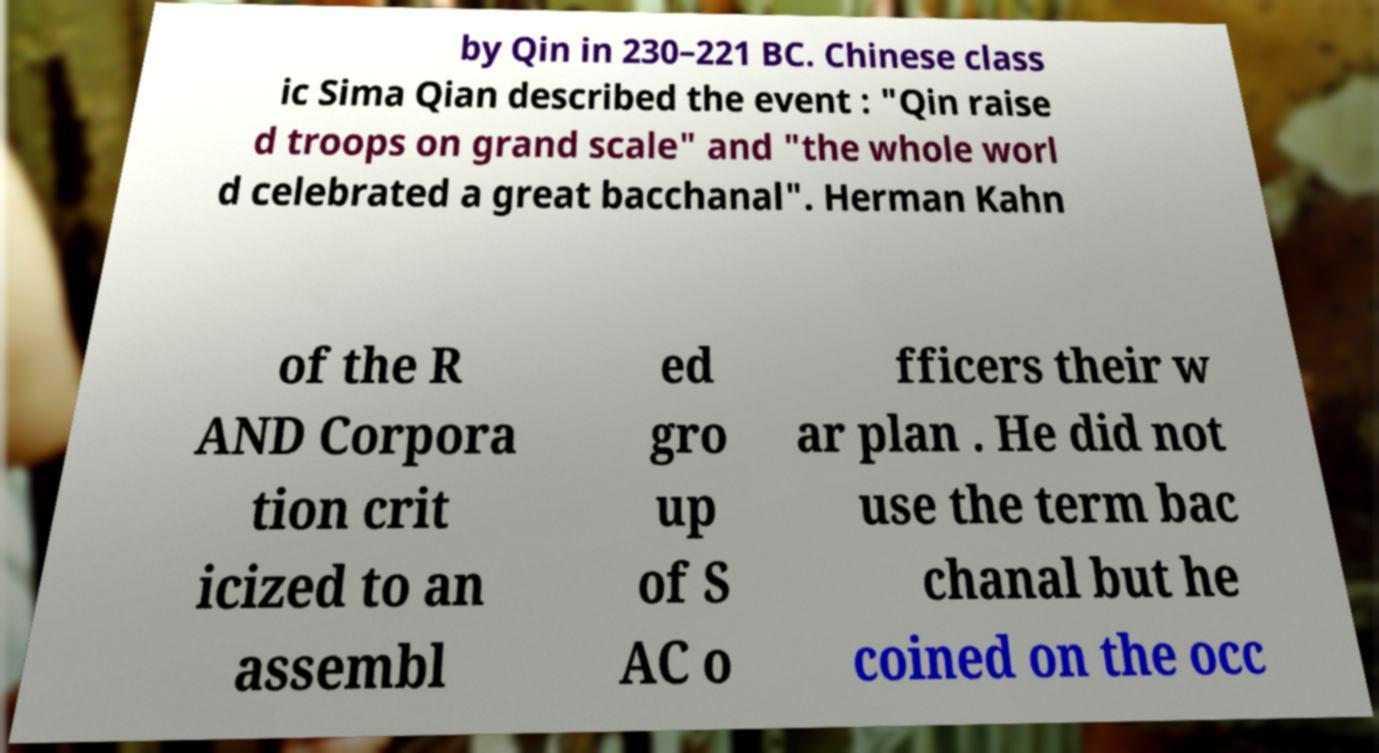Can you accurately transcribe the text from the provided image for me? by Qin in 230–221 BC. Chinese class ic Sima Qian described the event : "Qin raise d troops on grand scale" and "the whole worl d celebrated a great bacchanal". Herman Kahn of the R AND Corpora tion crit icized to an assembl ed gro up of S AC o fficers their w ar plan . He did not use the term bac chanal but he coined on the occ 